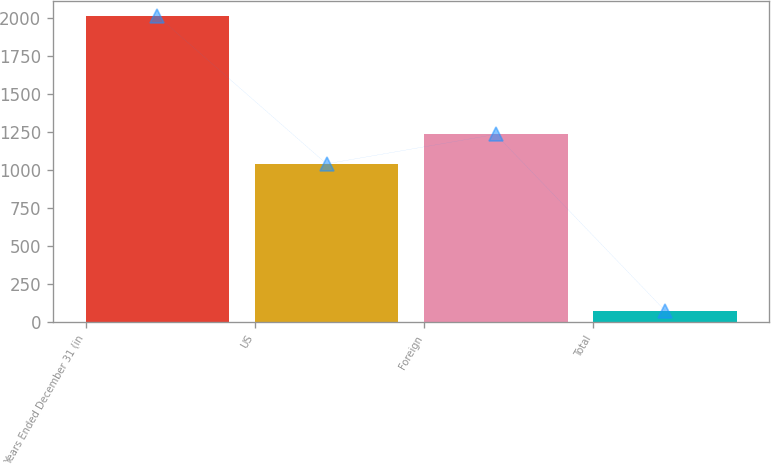Convert chart to OTSL. <chart><loc_0><loc_0><loc_500><loc_500><bar_chart><fcel>Years Ended December 31 (in<fcel>US<fcel>Foreign<fcel>Total<nl><fcel>2016<fcel>1041<fcel>1235.2<fcel>74<nl></chart> 